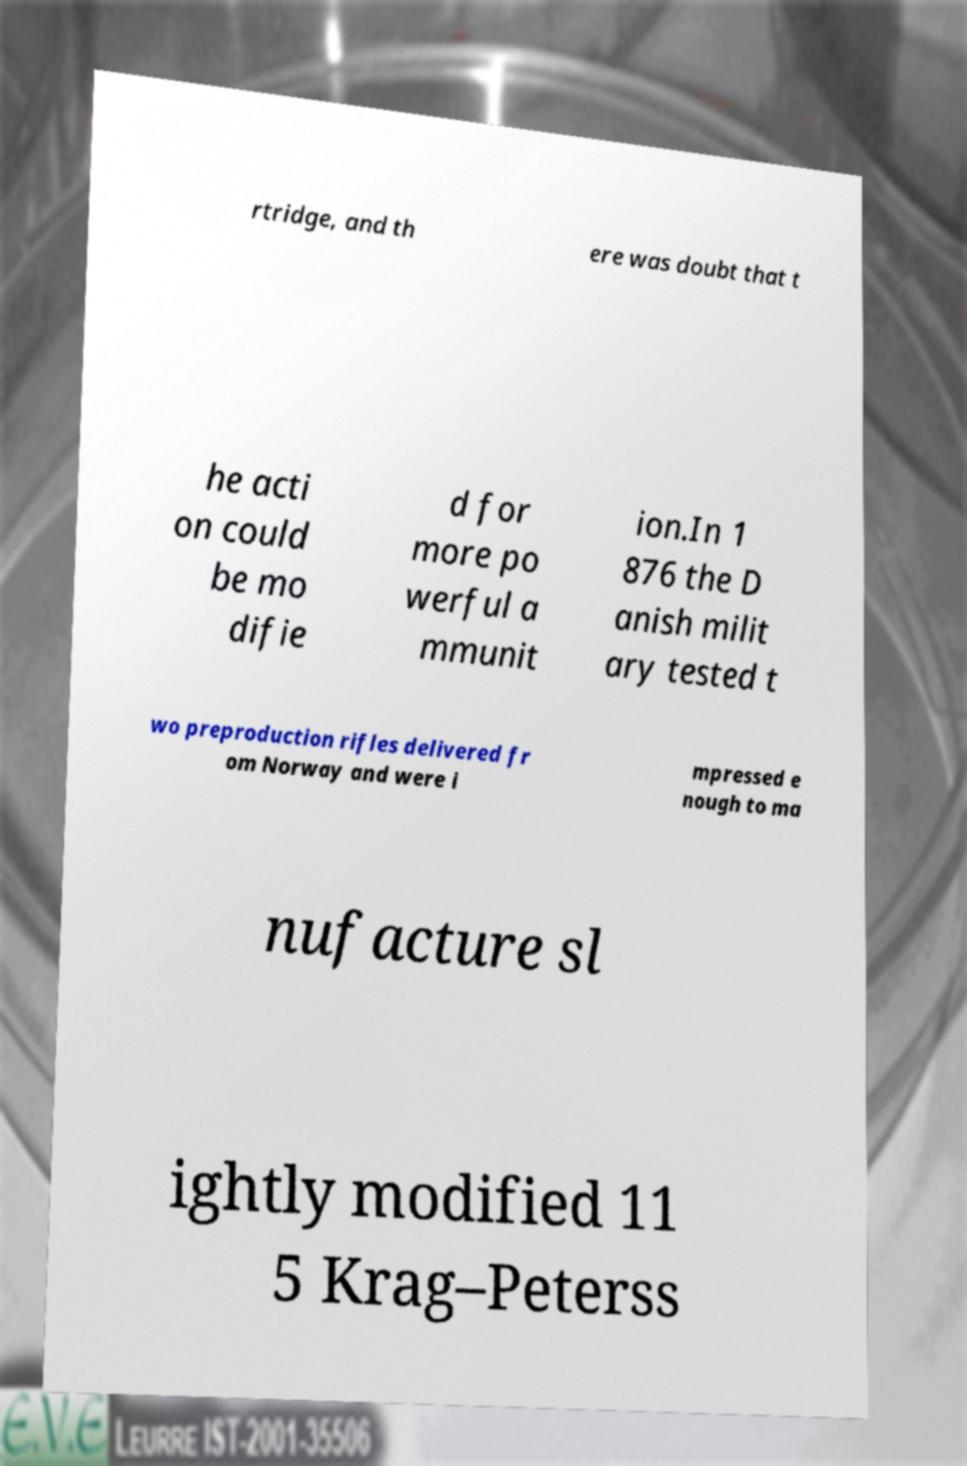For documentation purposes, I need the text within this image transcribed. Could you provide that? rtridge, and th ere was doubt that t he acti on could be mo difie d for more po werful a mmunit ion.In 1 876 the D anish milit ary tested t wo preproduction rifles delivered fr om Norway and were i mpressed e nough to ma nufacture sl ightly modified 11 5 Krag–Peterss 